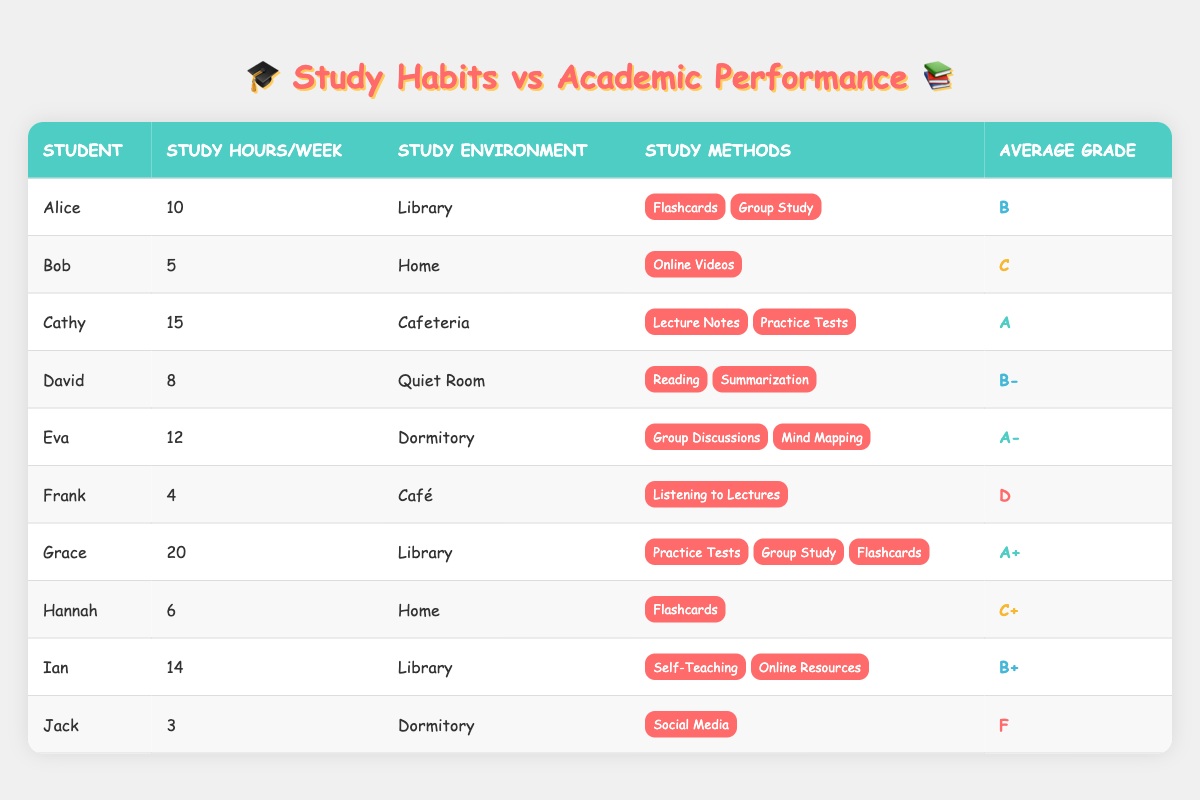What is the average grade of students studying for more than 10 hours per week? The students who study more than 10 hours per week are Cathy (A), Eva (A-), Grace (A+), and Ian (B+). Adding their grades, we note the grade points for A (4), A- (3.7), A+ (4.3), and B+ (3.3). Calculating the average: (4 + 3.7 + 4.3 + 3.3) / 4 = 15.3 / 4 = 3.825, which corresponds to an average grade of approximately B+
Answer: B+ Which student has the lowest study hours per week and what is their average grade? The student with the lowest study hours is Jack, who studies for 3 hours and has an average grade of F
Answer: Jack, F Do students studying in a Library environment tend to have higher average grades than those studying at Home? Students studying in a Library: Alice (B), Cathy (A), Grace (A+), Ian (B+) gives an average: (3 + 4 + 4.3 + 3.3) / 4 = 14.6 / 4 = 3.65 (B). Home: Bob (C) and Hannah (C+) average: (2 + 2.3) / 2 = 4.3 / 2 = 2.15 (C). Library students have higher averages than Home students.
Answer: Yes How many students use more than one study method and what are their grades? The students using more than one method are Alice (B), Cathy (A), Eva (A-), Grace (A+), and Hannah (C+). Their grades are: B, A, A-, A+, C+. Counting them gives 5 students.
Answer: 5 students; Grades: B, A, A-, A+, C+ Is there a direct correlation between study hours and average grade among the students? To determine correlation, we can look for patterns. Higher study hours predominantly correlate with higher grades (e.g., Grace at 20 hours with A+), but exceptions exist (e.g., Bob at 5 hours with C). While higher hours help, it’s not absolute due to varying study methods.
Answer: No, it's not a direct correlation 